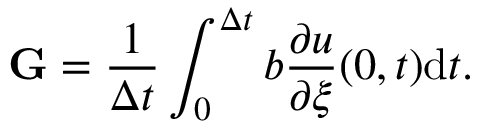Convert formula to latex. <formula><loc_0><loc_0><loc_500><loc_500>G = \frac { 1 } { \Delta t } \int _ { 0 } ^ { \Delta t } b \frac { \partial u } { \partial \xi } ( 0 , t ) d t .</formula> 